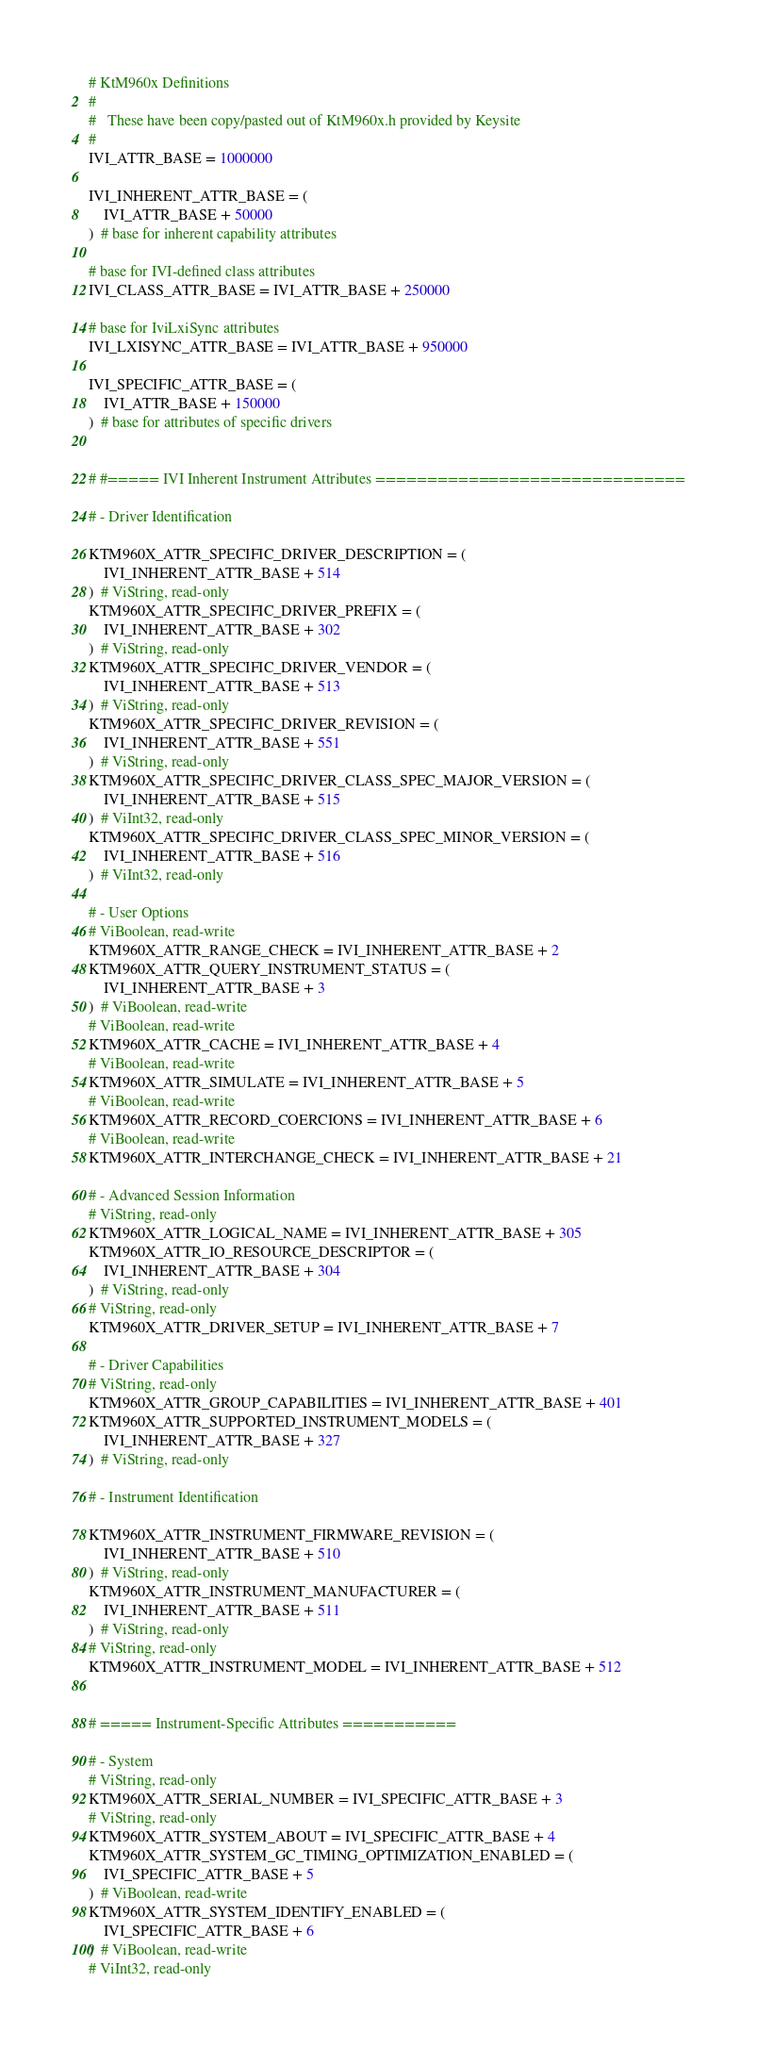<code> <loc_0><loc_0><loc_500><loc_500><_Python_># KtM960x Definitions
#
#   These have been copy/pasted out of KtM960x.h provided by Keysite
#
IVI_ATTR_BASE = 1000000

IVI_INHERENT_ATTR_BASE = (
    IVI_ATTR_BASE + 50000
)  # base for inherent capability attributes

# base for IVI-defined class attributes
IVI_CLASS_ATTR_BASE = IVI_ATTR_BASE + 250000

# base for IviLxiSync attributes
IVI_LXISYNC_ATTR_BASE = IVI_ATTR_BASE + 950000

IVI_SPECIFIC_ATTR_BASE = (
    IVI_ATTR_BASE + 150000
)  # base for attributes of specific drivers


# #===== IVI Inherent Instrument Attributes ==============================

# - Driver Identification

KTM960X_ATTR_SPECIFIC_DRIVER_DESCRIPTION = (
    IVI_INHERENT_ATTR_BASE + 514
)  # ViString, read-only
KTM960X_ATTR_SPECIFIC_DRIVER_PREFIX = (
    IVI_INHERENT_ATTR_BASE + 302
)  # ViString, read-only
KTM960X_ATTR_SPECIFIC_DRIVER_VENDOR = (
    IVI_INHERENT_ATTR_BASE + 513
)  # ViString, read-only
KTM960X_ATTR_SPECIFIC_DRIVER_REVISION = (
    IVI_INHERENT_ATTR_BASE + 551
)  # ViString, read-only
KTM960X_ATTR_SPECIFIC_DRIVER_CLASS_SPEC_MAJOR_VERSION = (
    IVI_INHERENT_ATTR_BASE + 515
)  # ViInt32, read-only
KTM960X_ATTR_SPECIFIC_DRIVER_CLASS_SPEC_MINOR_VERSION = (
    IVI_INHERENT_ATTR_BASE + 516
)  # ViInt32, read-only

# - User Options
# ViBoolean, read-write
KTM960X_ATTR_RANGE_CHECK = IVI_INHERENT_ATTR_BASE + 2
KTM960X_ATTR_QUERY_INSTRUMENT_STATUS = (
    IVI_INHERENT_ATTR_BASE + 3
)  # ViBoolean, read-write
# ViBoolean, read-write
KTM960X_ATTR_CACHE = IVI_INHERENT_ATTR_BASE + 4
# ViBoolean, read-write
KTM960X_ATTR_SIMULATE = IVI_INHERENT_ATTR_BASE + 5
# ViBoolean, read-write
KTM960X_ATTR_RECORD_COERCIONS = IVI_INHERENT_ATTR_BASE + 6
# ViBoolean, read-write
KTM960X_ATTR_INTERCHANGE_CHECK = IVI_INHERENT_ATTR_BASE + 21

# - Advanced Session Information
# ViString, read-only
KTM960X_ATTR_LOGICAL_NAME = IVI_INHERENT_ATTR_BASE + 305
KTM960X_ATTR_IO_RESOURCE_DESCRIPTOR = (
    IVI_INHERENT_ATTR_BASE + 304
)  # ViString, read-only
# ViString, read-only
KTM960X_ATTR_DRIVER_SETUP = IVI_INHERENT_ATTR_BASE + 7

# - Driver Capabilities
# ViString, read-only
KTM960X_ATTR_GROUP_CAPABILITIES = IVI_INHERENT_ATTR_BASE + 401
KTM960X_ATTR_SUPPORTED_INSTRUMENT_MODELS = (
    IVI_INHERENT_ATTR_BASE + 327
)  # ViString, read-only

# - Instrument Identification

KTM960X_ATTR_INSTRUMENT_FIRMWARE_REVISION = (
    IVI_INHERENT_ATTR_BASE + 510
)  # ViString, read-only
KTM960X_ATTR_INSTRUMENT_MANUFACTURER = (
    IVI_INHERENT_ATTR_BASE + 511
)  # ViString, read-only
# ViString, read-only
KTM960X_ATTR_INSTRUMENT_MODEL = IVI_INHERENT_ATTR_BASE + 512


# ===== Instrument-Specific Attributes ===========

# - System
# ViString, read-only
KTM960X_ATTR_SERIAL_NUMBER = IVI_SPECIFIC_ATTR_BASE + 3
# ViString, read-only
KTM960X_ATTR_SYSTEM_ABOUT = IVI_SPECIFIC_ATTR_BASE + 4
KTM960X_ATTR_SYSTEM_GC_TIMING_OPTIMIZATION_ENABLED = (
    IVI_SPECIFIC_ATTR_BASE + 5
)  # ViBoolean, read-write
KTM960X_ATTR_SYSTEM_IDENTIFY_ENABLED = (
    IVI_SPECIFIC_ATTR_BASE + 6
)  # ViBoolean, read-write
# ViInt32, read-only</code> 